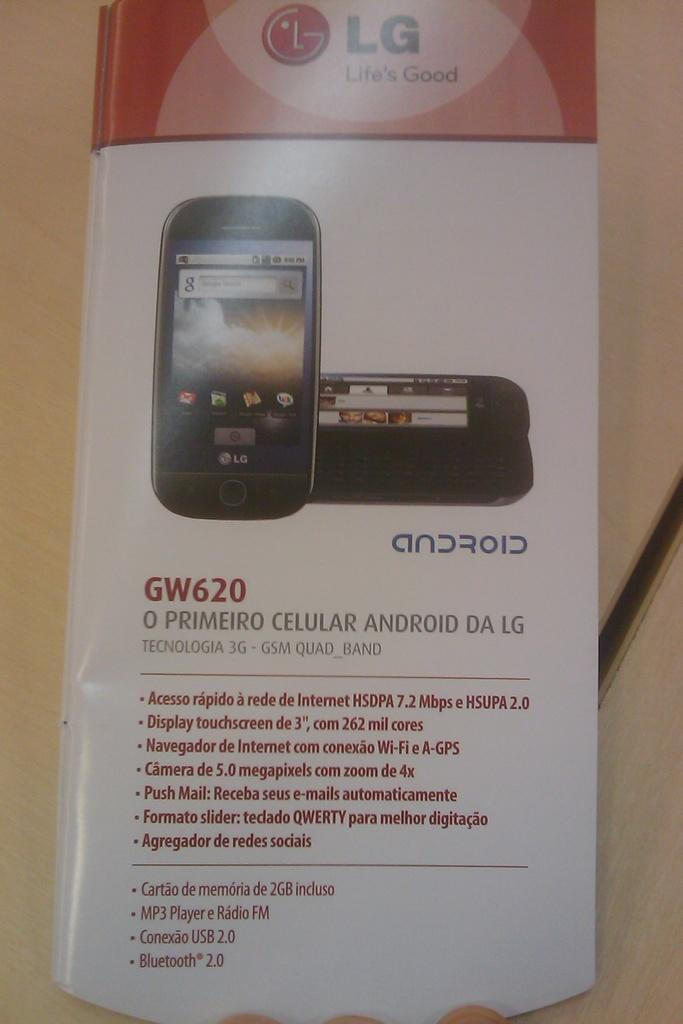<image>
Create a compact narrative representing the image presented. The specifications for a LG GW620 phone with Android. 